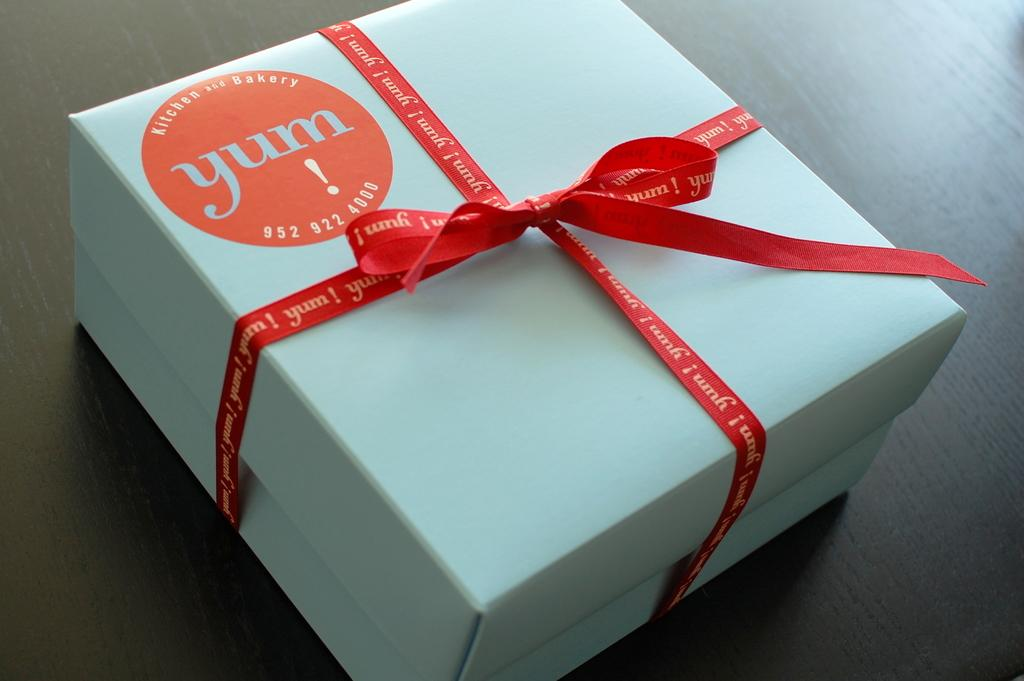<image>
Offer a succinct explanation of the picture presented. A blue box for "Yum" is tied with a red ribbon. 